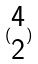<formula> <loc_0><loc_0><loc_500><loc_500>( \begin{matrix} 4 \\ 2 \end{matrix} )</formula> 